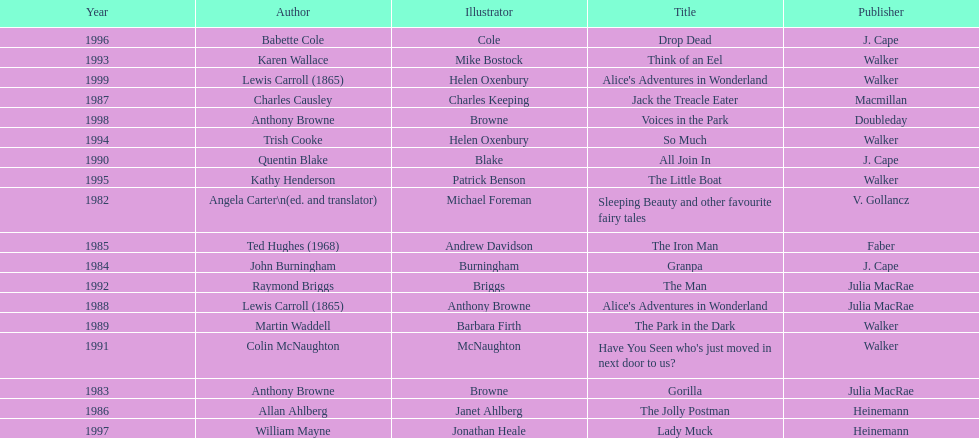Which author wrote the first award winner? Angela Carter. 